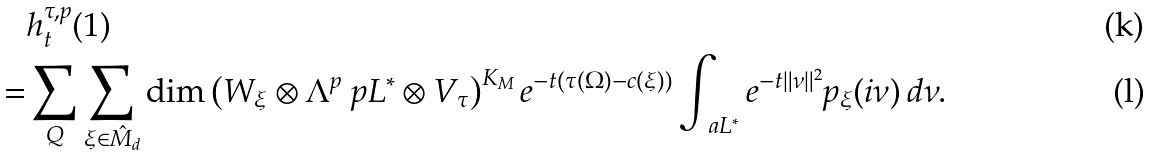Convert formula to latex. <formula><loc_0><loc_0><loc_500><loc_500>& h _ { t } ^ { \tau , p } ( 1 ) \\ = & \sum _ { Q } \sum _ { \xi \in \hat { M } _ { d } } \dim \left ( W _ { \xi } \otimes \Lambda ^ { p } \ p L ^ { * } \otimes V _ { \tau } \right ) ^ { K _ { M } } e ^ { - t ( \tau ( \Omega ) - c ( \xi ) ) } \int _ { \ a L ^ { * } } e ^ { - t \| \nu \| ^ { 2 } } p _ { \xi } ( i \nu ) \, d \nu .</formula> 